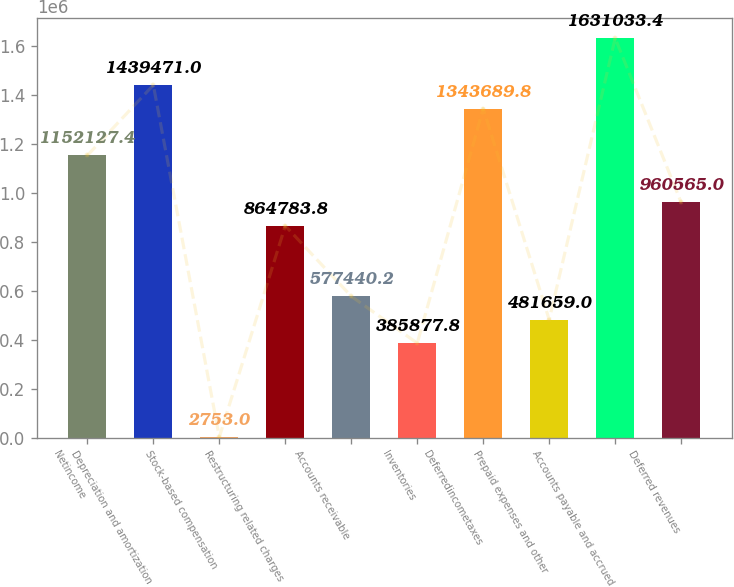<chart> <loc_0><loc_0><loc_500><loc_500><bar_chart><fcel>Netincome<fcel>Depreciation and amortization<fcel>Stock-based compensation<fcel>Restructuring related charges<fcel>Accounts receivable<fcel>Inventories<fcel>Deferredincometaxes<fcel>Prepaid expenses and other<fcel>Accounts payable and accrued<fcel>Deferred revenues<nl><fcel>1.15213e+06<fcel>1.43947e+06<fcel>2753<fcel>864784<fcel>577440<fcel>385878<fcel>1.34369e+06<fcel>481659<fcel>1.63103e+06<fcel>960565<nl></chart> 